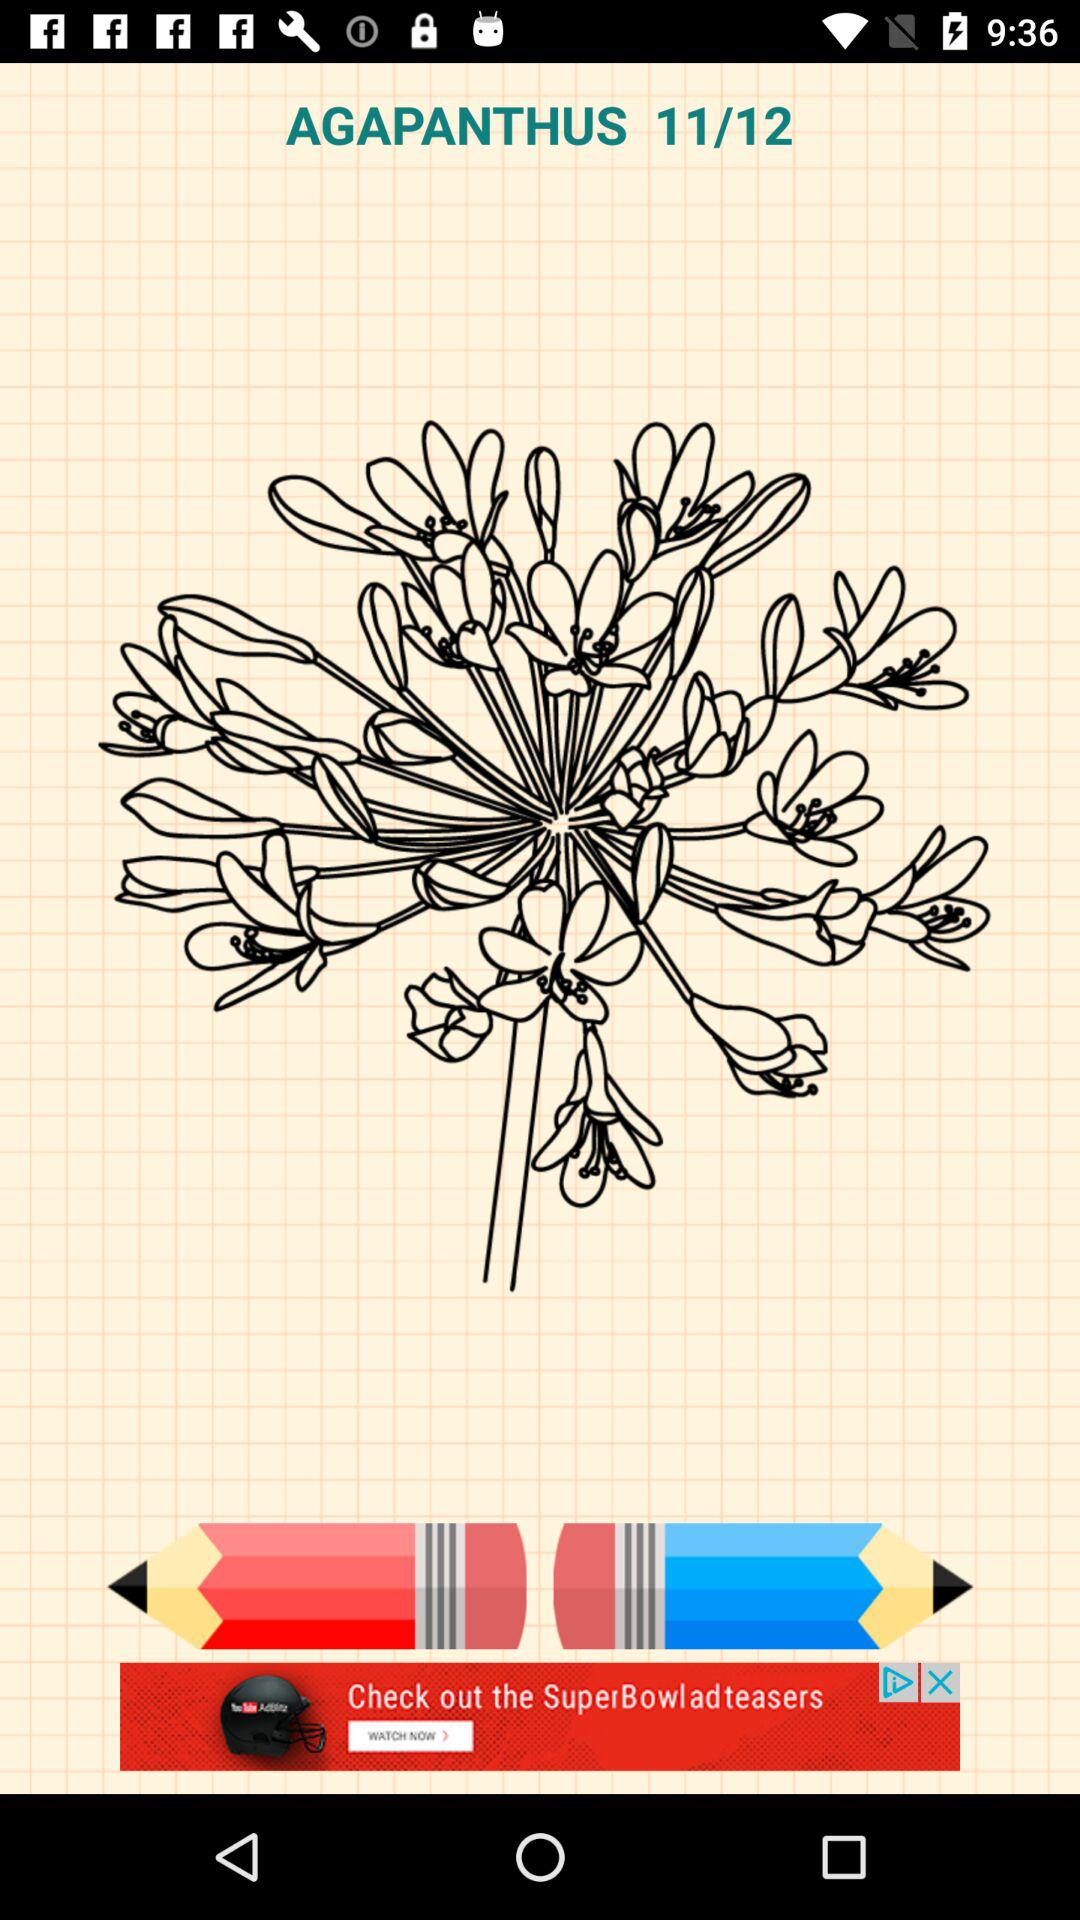What is the total number of images? The total number of images is 12. 